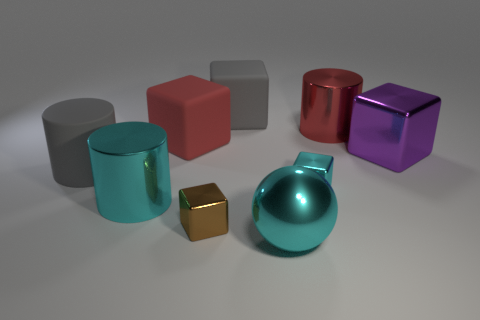Add 1 small cyan metallic spheres. How many objects exist? 10 Subtract all red metal cylinders. How many cylinders are left? 2 Subtract all cyan cylinders. How many cylinders are left? 2 Subtract all cylinders. How many objects are left? 6 Subtract 2 blocks. How many blocks are left? 3 Subtract all cyan cylinders. Subtract all gray balls. How many cylinders are left? 2 Subtract all green balls. How many yellow cylinders are left? 0 Subtract all large purple matte things. Subtract all big red cylinders. How many objects are left? 8 Add 2 red objects. How many red objects are left? 4 Add 2 large cyan spheres. How many large cyan spheres exist? 3 